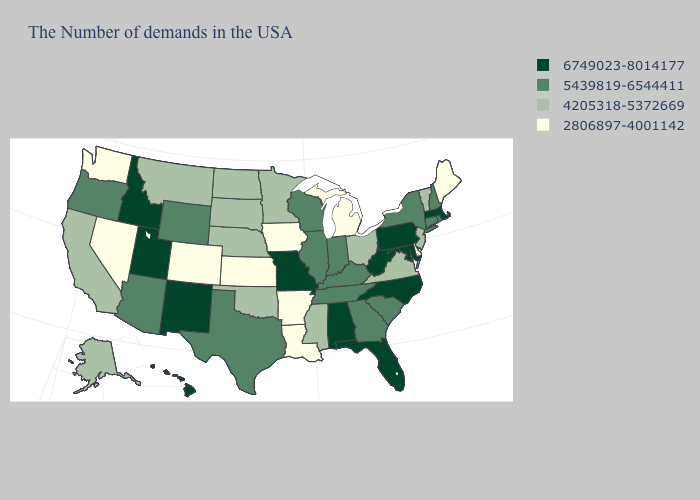What is the lowest value in the USA?
Be succinct. 2806897-4001142. What is the lowest value in the MidWest?
Concise answer only. 2806897-4001142. Does Virginia have the same value as California?
Concise answer only. Yes. Does Kansas have the lowest value in the USA?
Concise answer only. Yes. Name the states that have a value in the range 6749023-8014177?
Give a very brief answer. Massachusetts, Maryland, Pennsylvania, North Carolina, West Virginia, Florida, Alabama, Missouri, New Mexico, Utah, Idaho, Hawaii. Does West Virginia have the lowest value in the USA?
Be succinct. No. What is the highest value in states that border Alabama?
Answer briefly. 6749023-8014177. What is the lowest value in the South?
Keep it brief. 2806897-4001142. What is the value of New Mexico?
Keep it brief. 6749023-8014177. Does Maryland have the highest value in the South?
Answer briefly. Yes. What is the lowest value in states that border Connecticut?
Write a very short answer. 5439819-6544411. Is the legend a continuous bar?
Write a very short answer. No. What is the value of Alaska?
Give a very brief answer. 4205318-5372669. Does Washington have the lowest value in the West?
Be succinct. Yes. What is the value of Virginia?
Short answer required. 4205318-5372669. 